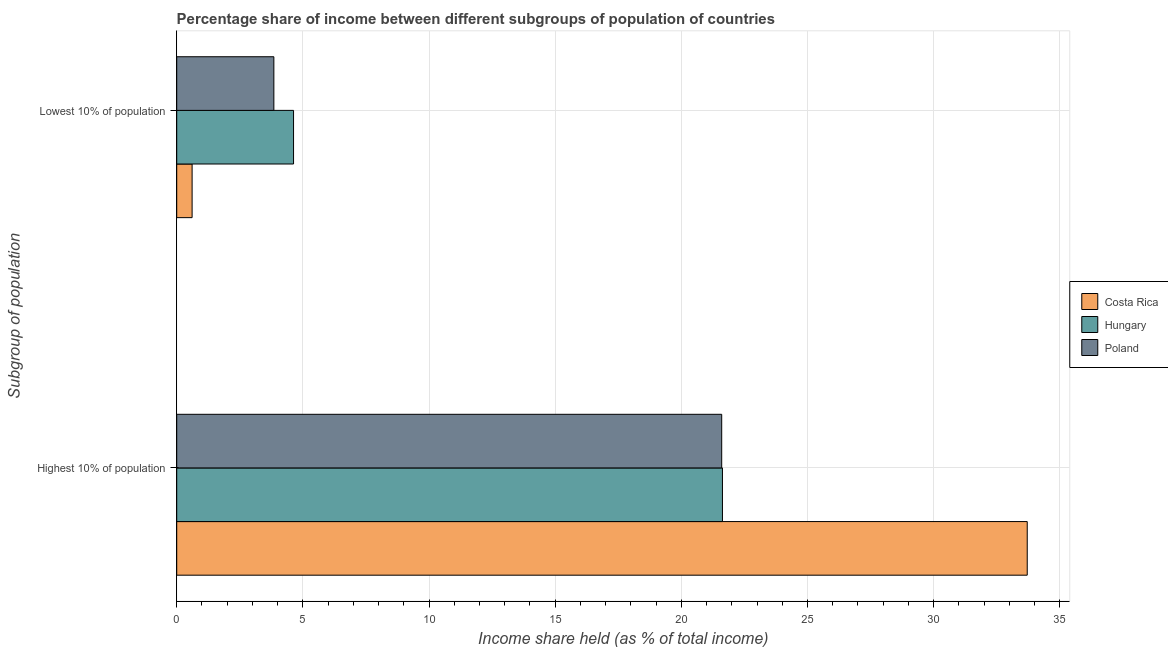How many groups of bars are there?
Provide a short and direct response. 2. Are the number of bars per tick equal to the number of legend labels?
Offer a terse response. Yes. How many bars are there on the 1st tick from the top?
Ensure brevity in your answer.  3. How many bars are there on the 1st tick from the bottom?
Give a very brief answer. 3. What is the label of the 2nd group of bars from the top?
Keep it short and to the point. Highest 10% of population. What is the income share held by highest 10% of the population in Hungary?
Offer a very short reply. 21.63. Across all countries, what is the maximum income share held by lowest 10% of the population?
Your response must be concise. 4.63. Across all countries, what is the minimum income share held by highest 10% of the population?
Give a very brief answer. 21.6. In which country was the income share held by lowest 10% of the population maximum?
Keep it short and to the point. Hungary. What is the total income share held by highest 10% of the population in the graph?
Give a very brief answer. 76.94. What is the difference between the income share held by highest 10% of the population in Costa Rica and that in Hungary?
Give a very brief answer. 12.08. What is the difference between the income share held by lowest 10% of the population in Poland and the income share held by highest 10% of the population in Hungary?
Your answer should be very brief. -17.78. What is the average income share held by highest 10% of the population per country?
Your answer should be very brief. 25.65. What is the difference between the income share held by highest 10% of the population and income share held by lowest 10% of the population in Costa Rica?
Provide a succinct answer. 33.1. What is the ratio of the income share held by highest 10% of the population in Costa Rica to that in Hungary?
Give a very brief answer. 1.56. Is the income share held by highest 10% of the population in Costa Rica less than that in Poland?
Ensure brevity in your answer.  No. In how many countries, is the income share held by highest 10% of the population greater than the average income share held by highest 10% of the population taken over all countries?
Ensure brevity in your answer.  1. Are all the bars in the graph horizontal?
Provide a succinct answer. Yes. How many countries are there in the graph?
Give a very brief answer. 3. Are the values on the major ticks of X-axis written in scientific E-notation?
Keep it short and to the point. No. Does the graph contain grids?
Make the answer very short. Yes. How many legend labels are there?
Provide a short and direct response. 3. How are the legend labels stacked?
Give a very brief answer. Vertical. What is the title of the graph?
Provide a succinct answer. Percentage share of income between different subgroups of population of countries. What is the label or title of the X-axis?
Provide a succinct answer. Income share held (as % of total income). What is the label or title of the Y-axis?
Provide a short and direct response. Subgroup of population. What is the Income share held (as % of total income) of Costa Rica in Highest 10% of population?
Your answer should be very brief. 33.71. What is the Income share held (as % of total income) in Hungary in Highest 10% of population?
Ensure brevity in your answer.  21.63. What is the Income share held (as % of total income) of Poland in Highest 10% of population?
Your answer should be compact. 21.6. What is the Income share held (as % of total income) in Costa Rica in Lowest 10% of population?
Give a very brief answer. 0.61. What is the Income share held (as % of total income) in Hungary in Lowest 10% of population?
Your answer should be very brief. 4.63. What is the Income share held (as % of total income) of Poland in Lowest 10% of population?
Give a very brief answer. 3.85. Across all Subgroup of population, what is the maximum Income share held (as % of total income) in Costa Rica?
Your answer should be compact. 33.71. Across all Subgroup of population, what is the maximum Income share held (as % of total income) of Hungary?
Make the answer very short. 21.63. Across all Subgroup of population, what is the maximum Income share held (as % of total income) of Poland?
Make the answer very short. 21.6. Across all Subgroup of population, what is the minimum Income share held (as % of total income) of Costa Rica?
Keep it short and to the point. 0.61. Across all Subgroup of population, what is the minimum Income share held (as % of total income) of Hungary?
Offer a terse response. 4.63. Across all Subgroup of population, what is the minimum Income share held (as % of total income) in Poland?
Your response must be concise. 3.85. What is the total Income share held (as % of total income) of Costa Rica in the graph?
Your answer should be compact. 34.32. What is the total Income share held (as % of total income) in Hungary in the graph?
Offer a terse response. 26.26. What is the total Income share held (as % of total income) in Poland in the graph?
Provide a succinct answer. 25.45. What is the difference between the Income share held (as % of total income) of Costa Rica in Highest 10% of population and that in Lowest 10% of population?
Your answer should be compact. 33.1. What is the difference between the Income share held (as % of total income) in Poland in Highest 10% of population and that in Lowest 10% of population?
Your answer should be compact. 17.75. What is the difference between the Income share held (as % of total income) in Costa Rica in Highest 10% of population and the Income share held (as % of total income) in Hungary in Lowest 10% of population?
Provide a short and direct response. 29.08. What is the difference between the Income share held (as % of total income) of Costa Rica in Highest 10% of population and the Income share held (as % of total income) of Poland in Lowest 10% of population?
Make the answer very short. 29.86. What is the difference between the Income share held (as % of total income) in Hungary in Highest 10% of population and the Income share held (as % of total income) in Poland in Lowest 10% of population?
Keep it short and to the point. 17.78. What is the average Income share held (as % of total income) in Costa Rica per Subgroup of population?
Your answer should be compact. 17.16. What is the average Income share held (as % of total income) of Hungary per Subgroup of population?
Your answer should be compact. 13.13. What is the average Income share held (as % of total income) in Poland per Subgroup of population?
Ensure brevity in your answer.  12.72. What is the difference between the Income share held (as % of total income) of Costa Rica and Income share held (as % of total income) of Hungary in Highest 10% of population?
Keep it short and to the point. 12.08. What is the difference between the Income share held (as % of total income) of Costa Rica and Income share held (as % of total income) of Poland in Highest 10% of population?
Provide a succinct answer. 12.11. What is the difference between the Income share held (as % of total income) of Hungary and Income share held (as % of total income) of Poland in Highest 10% of population?
Your answer should be compact. 0.03. What is the difference between the Income share held (as % of total income) of Costa Rica and Income share held (as % of total income) of Hungary in Lowest 10% of population?
Ensure brevity in your answer.  -4.02. What is the difference between the Income share held (as % of total income) in Costa Rica and Income share held (as % of total income) in Poland in Lowest 10% of population?
Offer a very short reply. -3.24. What is the difference between the Income share held (as % of total income) in Hungary and Income share held (as % of total income) in Poland in Lowest 10% of population?
Your answer should be very brief. 0.78. What is the ratio of the Income share held (as % of total income) in Costa Rica in Highest 10% of population to that in Lowest 10% of population?
Your answer should be very brief. 55.26. What is the ratio of the Income share held (as % of total income) of Hungary in Highest 10% of population to that in Lowest 10% of population?
Your answer should be very brief. 4.67. What is the ratio of the Income share held (as % of total income) of Poland in Highest 10% of population to that in Lowest 10% of population?
Offer a terse response. 5.61. What is the difference between the highest and the second highest Income share held (as % of total income) of Costa Rica?
Offer a very short reply. 33.1. What is the difference between the highest and the second highest Income share held (as % of total income) in Poland?
Make the answer very short. 17.75. What is the difference between the highest and the lowest Income share held (as % of total income) of Costa Rica?
Offer a very short reply. 33.1. What is the difference between the highest and the lowest Income share held (as % of total income) of Poland?
Provide a succinct answer. 17.75. 